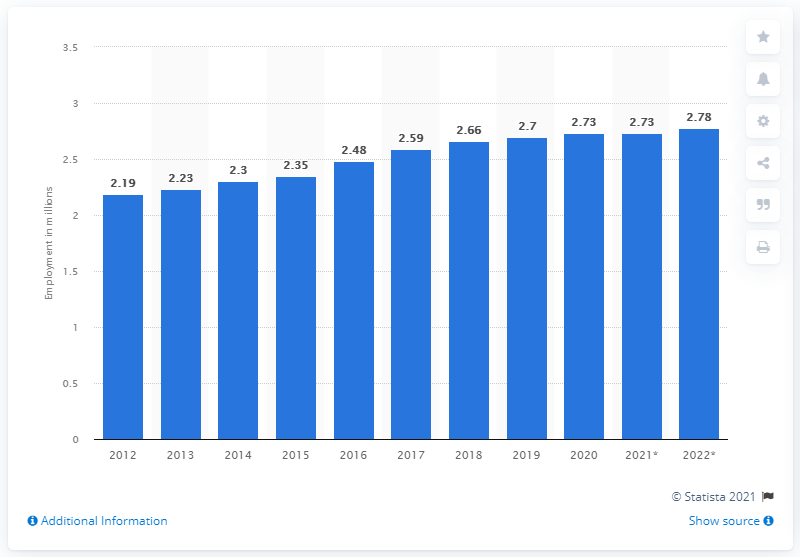Outline some significant characteristics in this image. In 2020, approximately 2.73 million people were employed in New Zealand. 